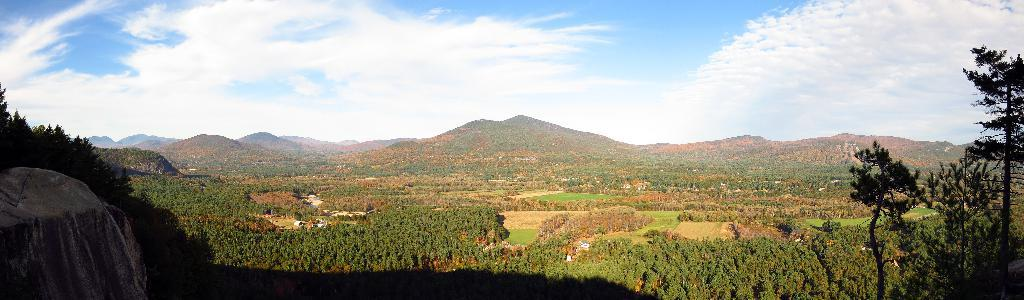What is the condition of the sky in the image? The sky is cloudy in the image. What can be seen in the background of the image? There are mountains in the distance in the image. What type of vegetation is visible in the image? There are multiple trees visible in the image. Where is the pin located in the image? There is no pin present in the image. What type of work is being done in the office shown in the image? There is no office present in the image. 